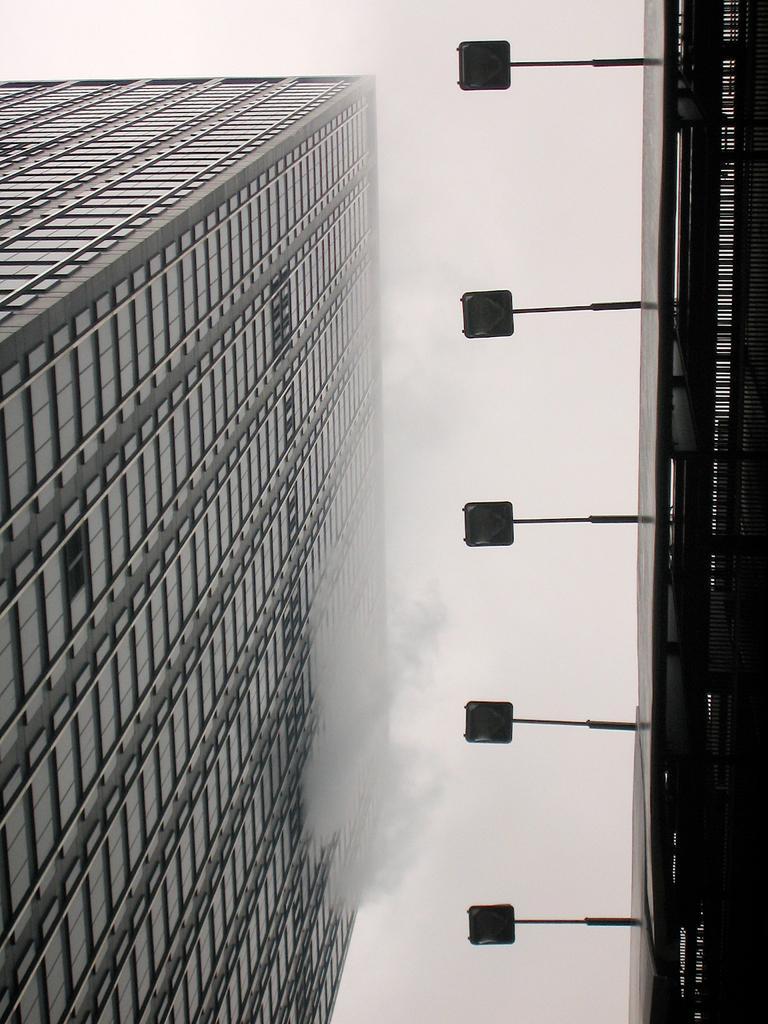In one or two sentences, can you explain what this image depicts? In this image we can see buildings, lights and sky. 